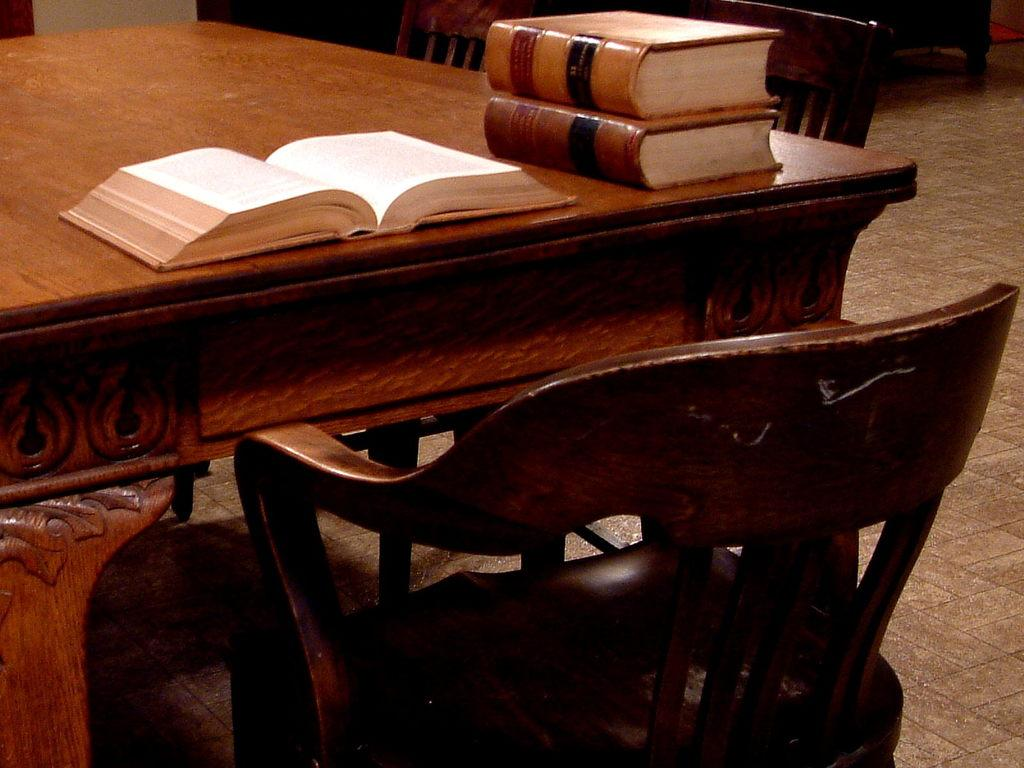What type of furniture is present in the image? There are chairs and a table in the image. What is located on the table in the image? There are books on the table in the image. What type of wool is used to make the books in the image? There is no wool present in the image; the books are made of paper or other materials typically used for book production. What type of feast is being held at the table in the image? There is no feast depicted in the image; the table only has books on it. 